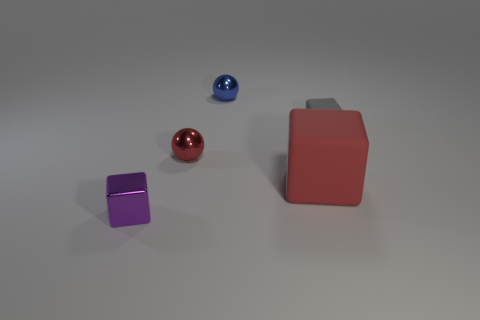Subtract all tiny shiny cubes. How many cubes are left? 2 Subtract all red blocks. How many blocks are left? 2 Subtract all balls. How many objects are left? 3 Add 4 gray rubber blocks. How many objects exist? 9 Subtract all cyan blocks. Subtract all green cylinders. How many blocks are left? 3 Subtract all gray cylinders. How many cyan blocks are left? 0 Subtract all big brown matte balls. Subtract all red blocks. How many objects are left? 4 Add 3 tiny purple cubes. How many tiny purple cubes are left? 4 Add 2 large blue balls. How many large blue balls exist? 2 Subtract 0 gray cylinders. How many objects are left? 5 